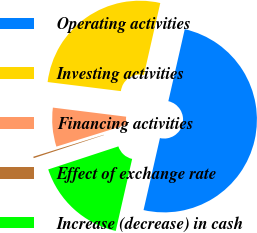Convert chart to OTSL. <chart><loc_0><loc_0><loc_500><loc_500><pie_chart><fcel>Operating activities<fcel>Investing activities<fcel>Financing activities<fcel>Effect of exchange rate<fcel>Increase (decrease) in cash<nl><fcel>50.0%<fcel>26.6%<fcel>6.77%<fcel>0.25%<fcel>16.38%<nl></chart> 